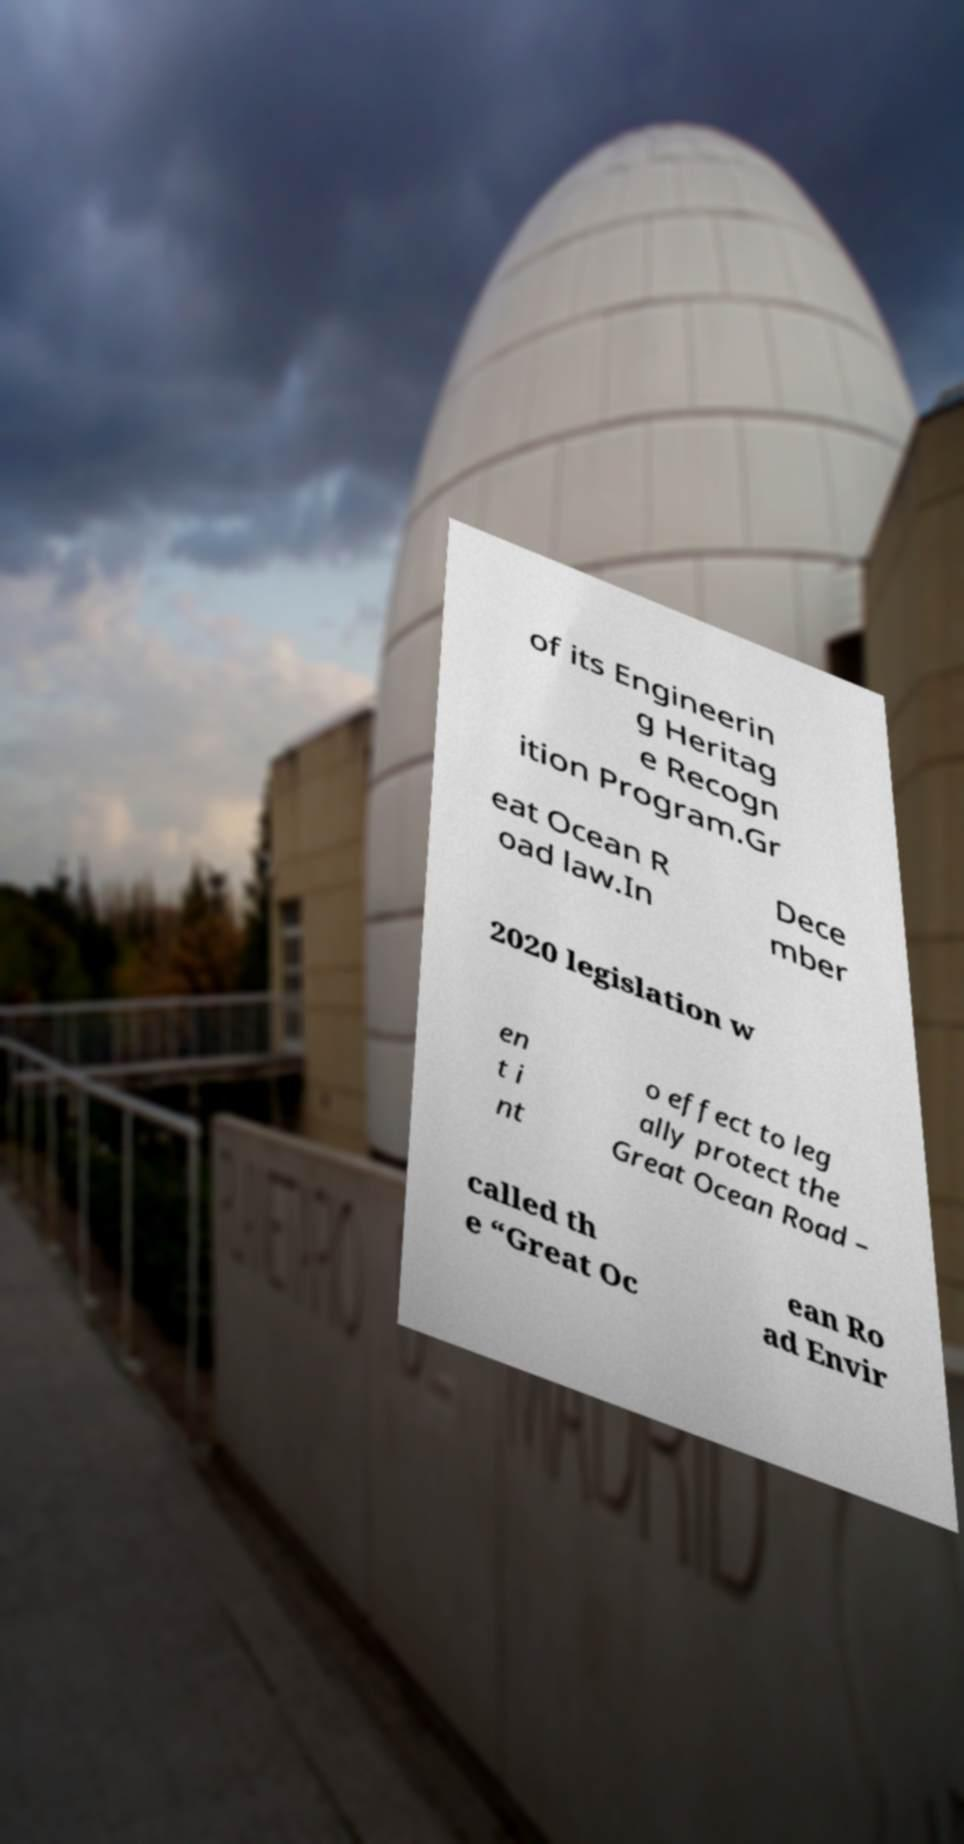There's text embedded in this image that I need extracted. Can you transcribe it verbatim? of its Engineerin g Heritag e Recogn ition Program.Gr eat Ocean R oad law.In Dece mber 2020 legislation w en t i nt o effect to leg ally protect the Great Ocean Road – called th e “Great Oc ean Ro ad Envir 